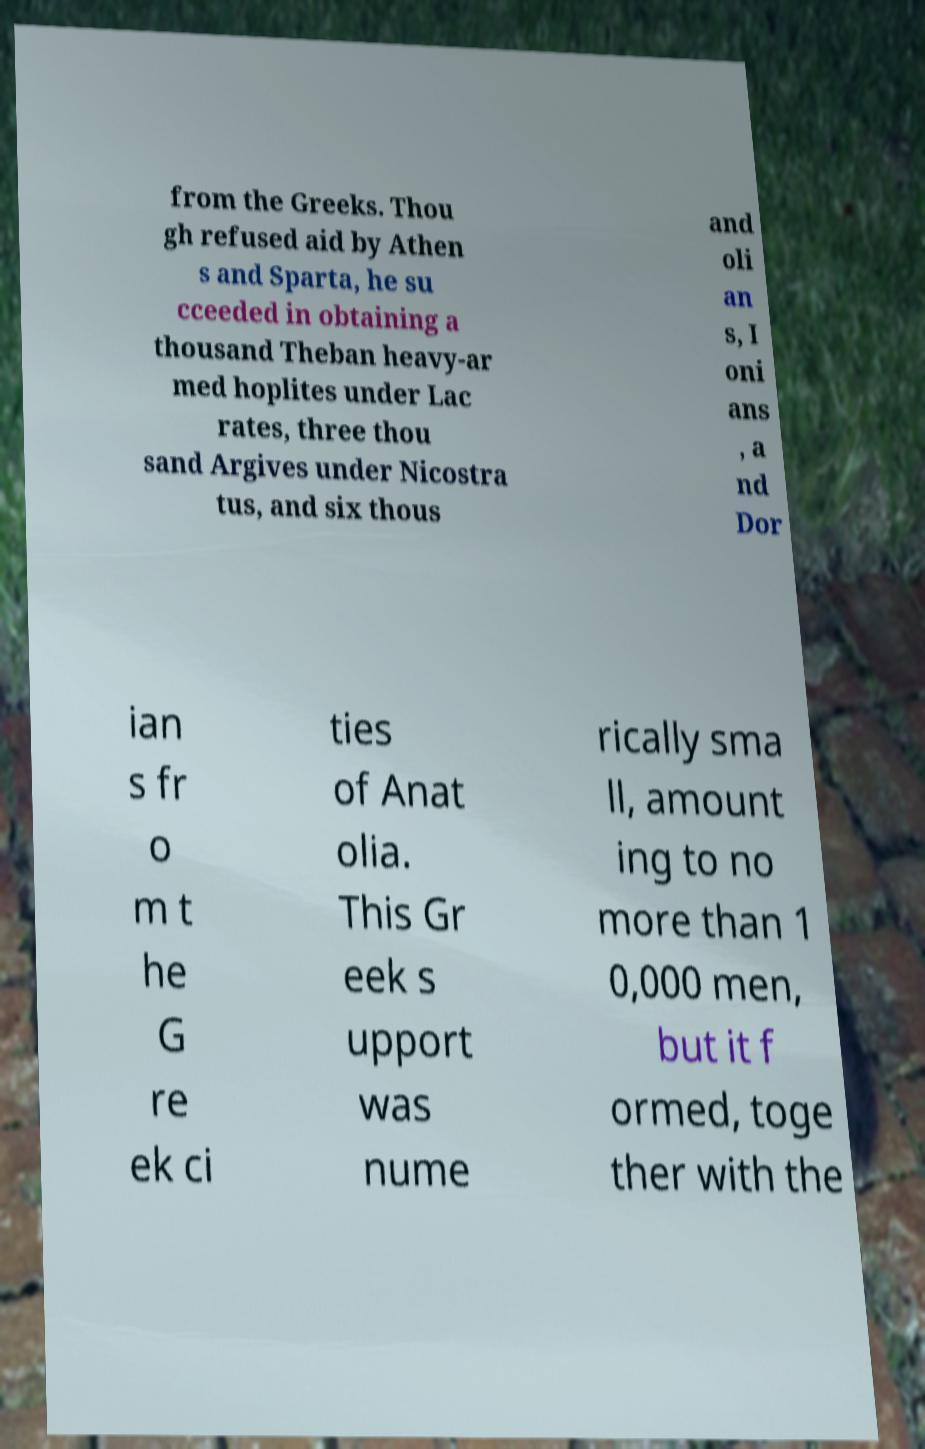I need the written content from this picture converted into text. Can you do that? from the Greeks. Thou gh refused aid by Athen s and Sparta, he su cceeded in obtaining a thousand Theban heavy-ar med hoplites under Lac rates, three thou sand Argives under Nicostra tus, and six thous and oli an s, I oni ans , a nd Dor ian s fr o m t he G re ek ci ties of Anat olia. This Gr eek s upport was nume rically sma ll, amount ing to no more than 1 0,000 men, but it f ormed, toge ther with the 